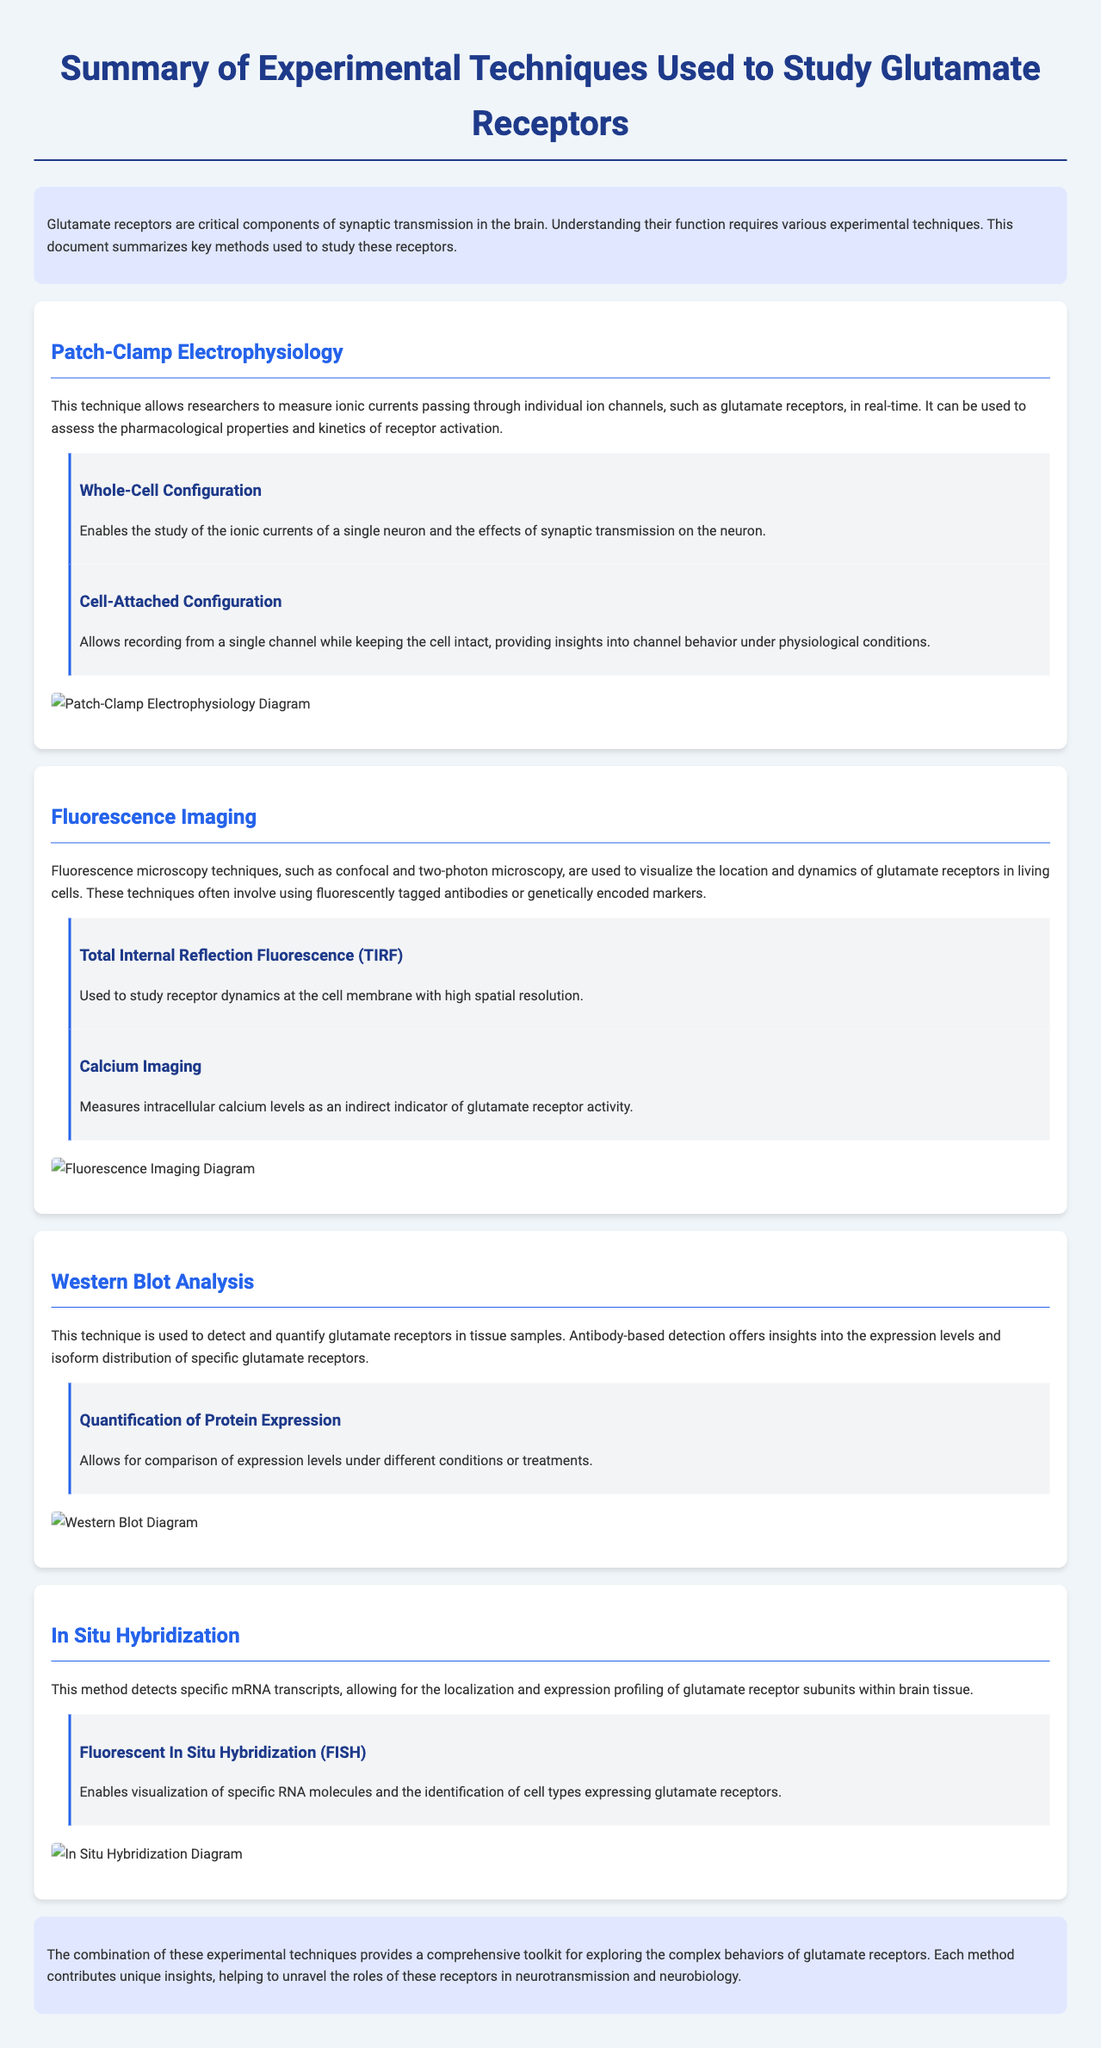What is the main focus of the document? The document summarizes experimental techniques used to study glutamate receptors, highlighting different methods and their purposes.
Answer: Experimental techniques used to study glutamate receptors What technique measures ionic currents through individual ion channels? The document states that patch-clamp electrophysiology is the method that allows researchers to measure ionic currents.
Answer: Patch-Clamp Electrophysiology Which imaging technique is utilized to visualize glutamate receptors in living cells? The document identifies fluorescence imaging techniques, including confocal and two-photon microscopy, for visualizing glutamate receptors.
Answer: Fluorescence Imaging What is one of the sub-methods associated with patch-clamp electrophysiology? The document lists "Whole-Cell Configuration" and "Cell-Attached Configuration" as sub-methods under patch-clamp electrophysiology.
Answer: Whole-Cell Configuration What does Western blot analysis detect? The document indicates that Western blot analysis is used to detect and quantify glutamate receptors in tissue samples.
Answer: Glutamate receptors What does in situ hybridization allow researchers to investigate? In situ hybridization enables the localization and expression profiling of glutamate receptor subunits within brain tissue.
Answer: Localization and expression profiling Which sub-method of fluorescence imaging provides high spatial resolution at the cell membrane? The document mentions Total Internal Reflection Fluorescence (TIRF) as the method used to study receptor dynamics at the cell membrane with high spatial resolution.
Answer: Total Internal Reflection Fluorescence (TIRF) What type of microscopy is mentioned for studying receptor dynamics? The document refers to confocal and two-photon microscopy as fluorescence microscopy techniques for studying glutamate receptor dynamics.
Answer: Confocal and two-photon microscopy What is the importance of combining different experimental techniques? The document concludes that combining these techniques provides a comprehensive toolkit for exploring the complex behaviors of glutamate receptors.
Answer: Comprehensive toolkit for exploring behaviors 